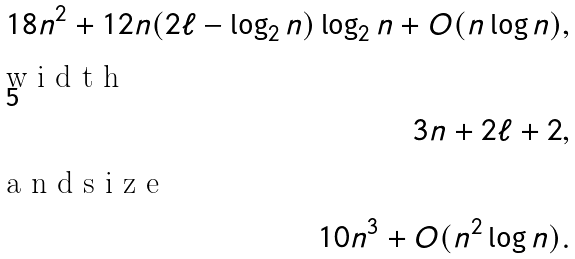Convert formula to latex. <formula><loc_0><loc_0><loc_500><loc_500>1 8 n ^ { 2 } + 1 2 n ( 2 \ell - \log _ { 2 } n ) \log _ { 2 } n + O ( n \log n ) , \intertext { w i d t h } 3 n + 2 \ell + 2 , \intertext { a n d s i z e } 1 0 n ^ { 3 } + O ( n ^ { 2 } \log n ) .</formula> 